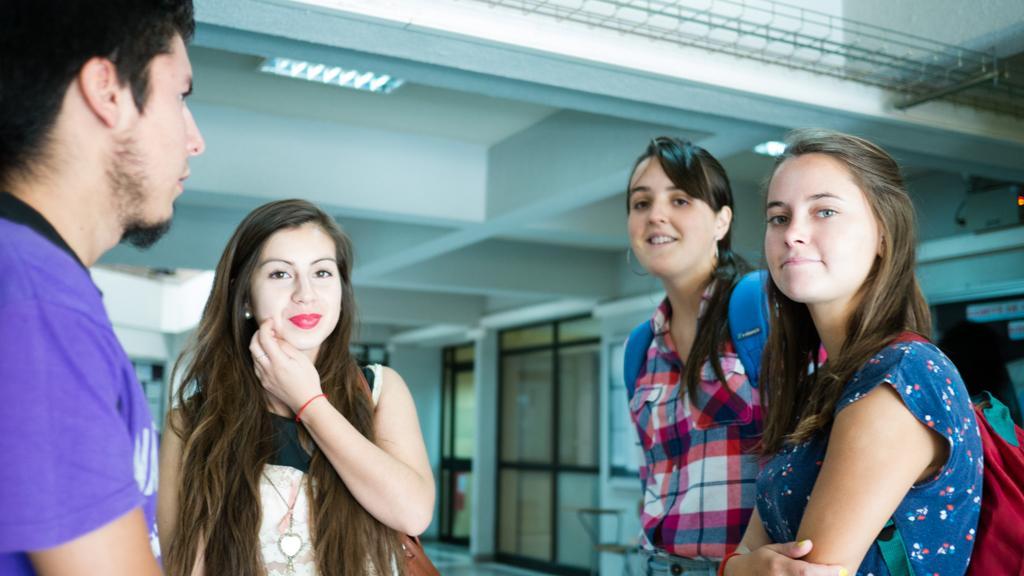How would you summarize this image in a sentence or two? This picture is clicked inside the hall. On the right we can see the two women wearing backpacks and standing. On the left we can see a woman wearing sling bag, smiling and standing and we can see a man standing. In the background we can see the doors, chair and some other objects. At the top there is a roof, lights, metal rods and some other objects. 